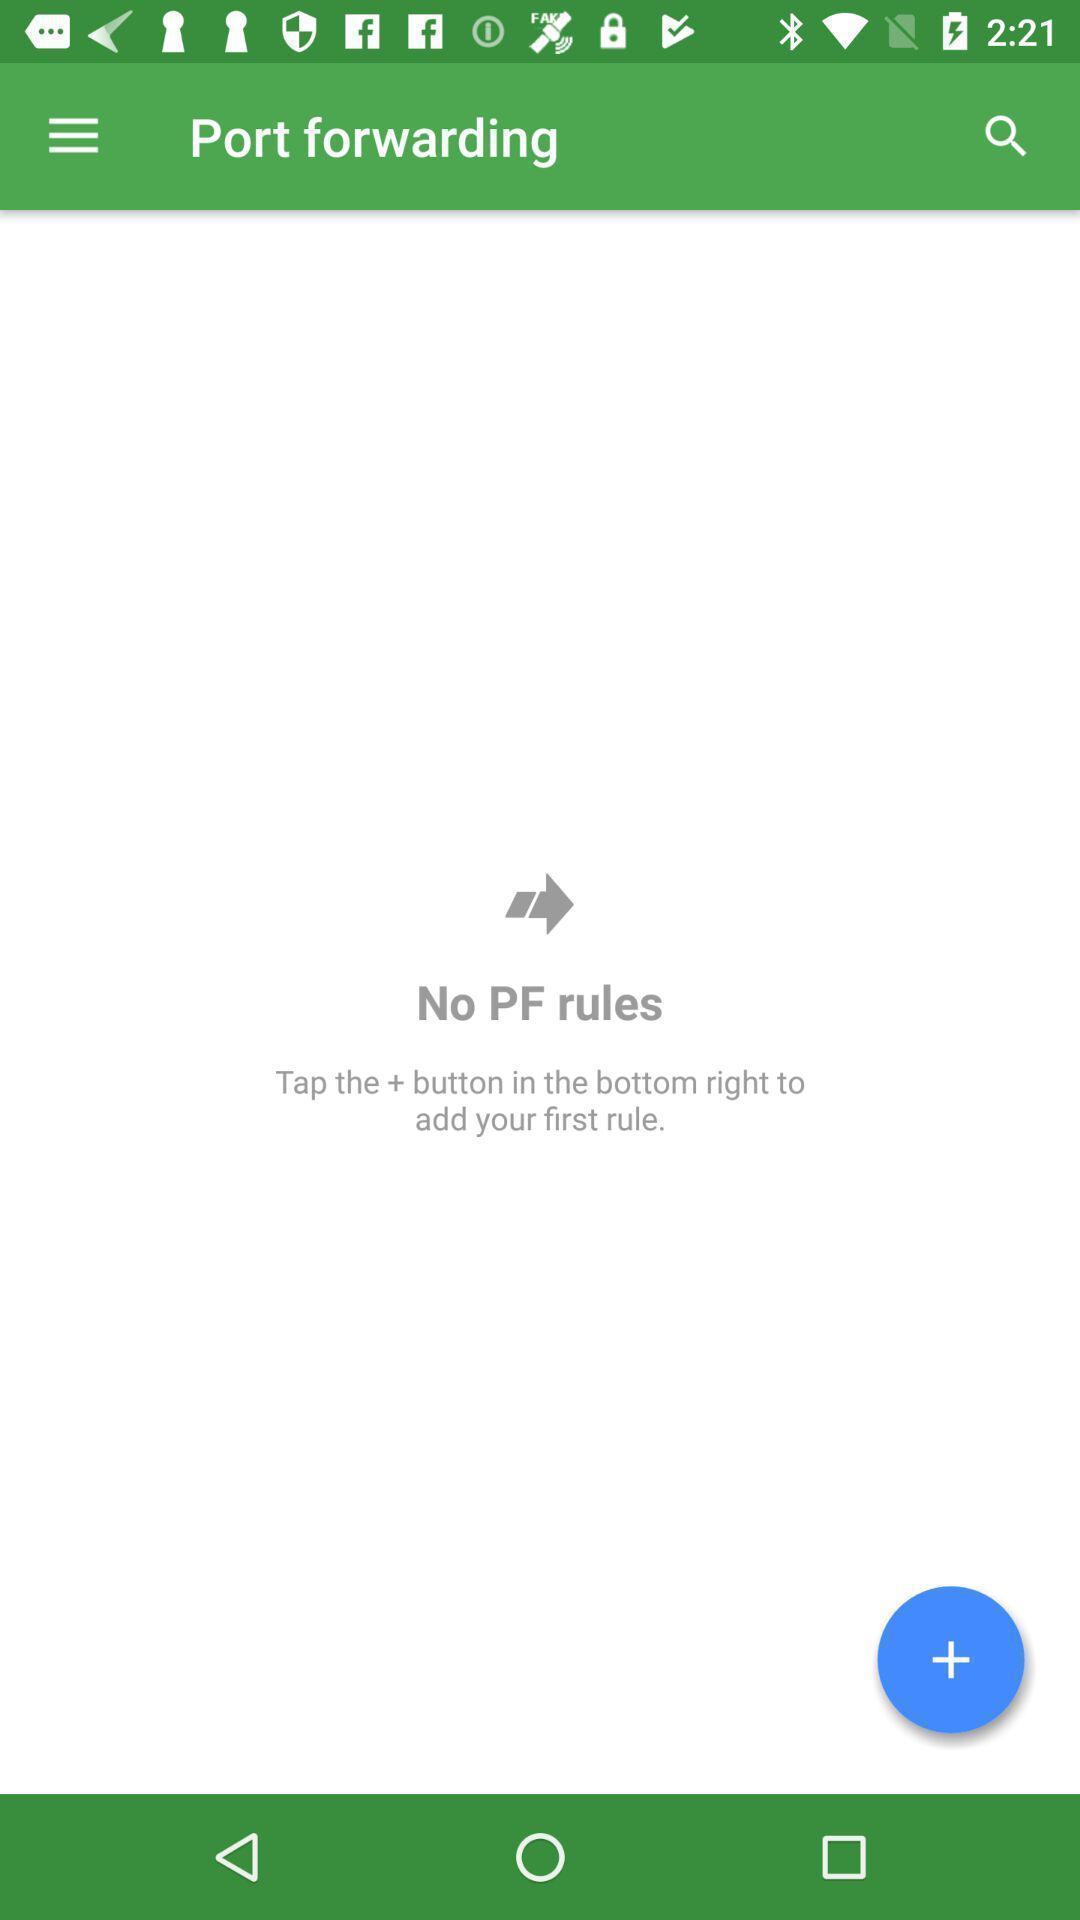Describe the key features of this screenshot. Page showing the blank in telecom application. 